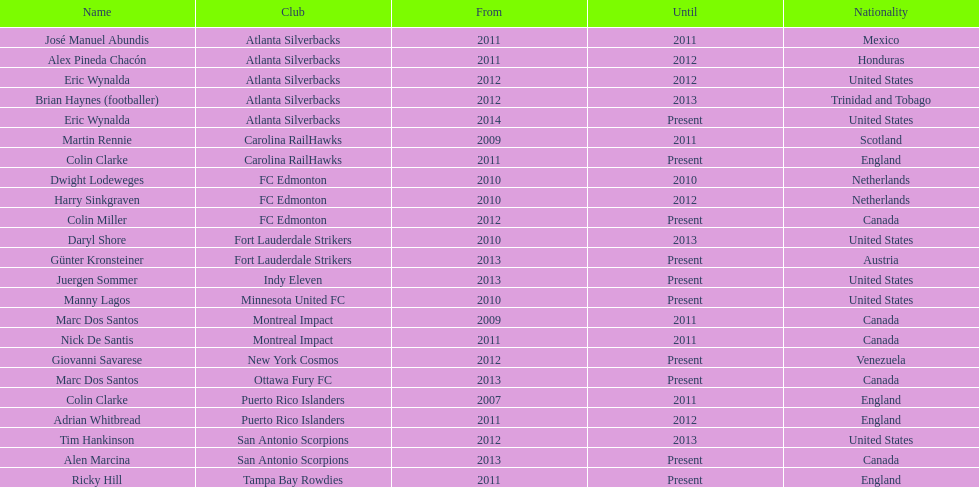Who is the last to coach the san antonio scorpions? Alen Marcina. 